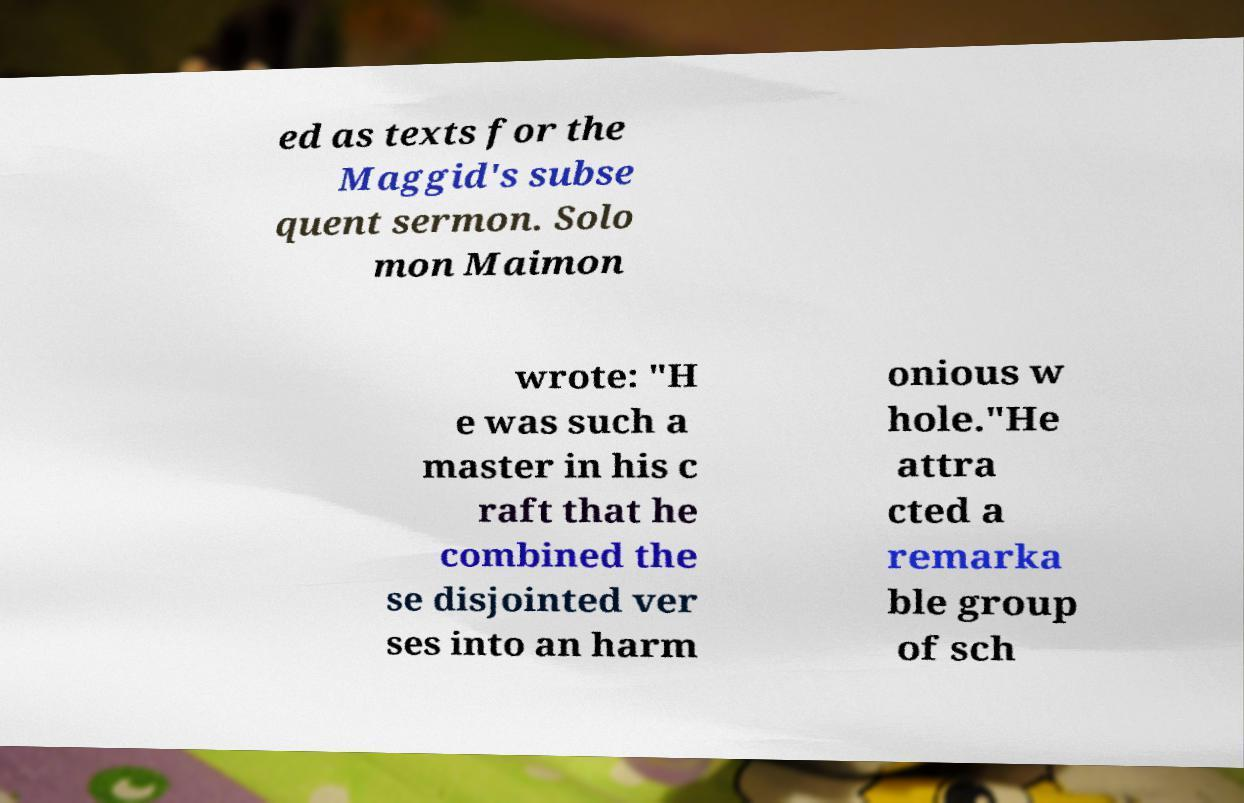There's text embedded in this image that I need extracted. Can you transcribe it verbatim? ed as texts for the Maggid's subse quent sermon. Solo mon Maimon wrote: "H e was such a master in his c raft that he combined the se disjointed ver ses into an harm onious w hole."He attra cted a remarka ble group of sch 